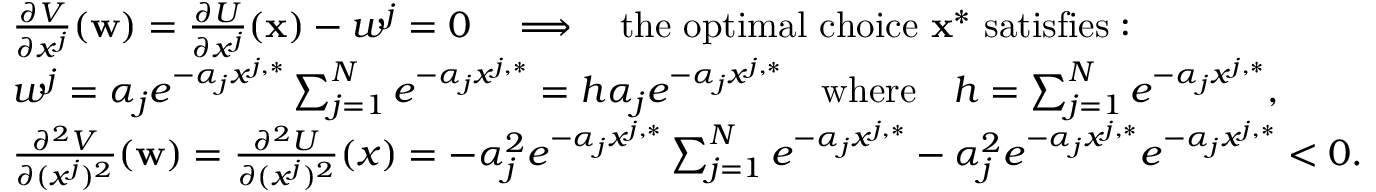<formula> <loc_0><loc_0><loc_500><loc_500>\begin{array} { r l } & { \frac { \partial V } { \partial x ^ { j } } ( w ) = \frac { \partial U } { \partial x ^ { j } } ( x ) - w ^ { j } = 0 \quad \Longrightarrow \quad t h e o p t i m a l c h o i c e x ^ { * } s a t i s f i e s \colon } \\ & { w ^ { j } = \alpha _ { j } e ^ { - \alpha _ { j } x ^ { j , * } } \sum _ { j = 1 } ^ { N } e ^ { - \alpha _ { j } x ^ { j , * } } = h \alpha _ { j } e ^ { - \alpha _ { j } x ^ { j , * } } \quad w h e r e \quad h = \sum _ { j = 1 } ^ { N } e ^ { - \alpha _ { j } x ^ { j , * } } , } \\ & { \frac { \partial ^ { 2 } V } { \partial ( x ^ { j } ) ^ { 2 } } ( w ) = \frac { \partial ^ { 2 } U } { \partial ( x ^ { j } ) ^ { 2 } } ( x ) = - \alpha _ { j } ^ { 2 } e ^ { - \alpha _ { j } x ^ { j , * } } \sum _ { j = 1 } ^ { N } e ^ { - \alpha _ { j } x ^ { j , * } } - \alpha _ { j } ^ { 2 } e ^ { - \alpha _ { j } x ^ { j , * } } e ^ { - \alpha _ { j } x ^ { j , * } } < 0 . } \end{array}</formula> 